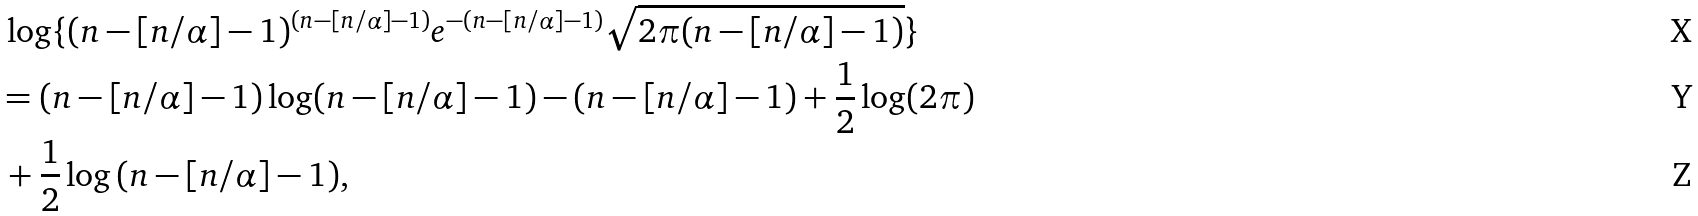<formula> <loc_0><loc_0><loc_500><loc_500>& \, \log \{ ( n - [ n / \alpha ] - 1 ) ^ { ( n - [ n / \alpha ] - 1 ) } e ^ { - ( n - [ n / \alpha ] - 1 ) } \sqrt { 2 \pi ( n - [ n / \alpha ] - 1 ) } \} \\ & = ( n - [ n / \alpha ] - 1 ) \log ( n - [ n / \alpha ] - 1 ) - ( n - [ n / \alpha ] - 1 ) + \frac { 1 } { 2 } \log ( 2 \pi ) \\ & \, + \frac { 1 } { 2 } \log { ( n - [ n / \alpha ] - 1 ) } ,</formula> 